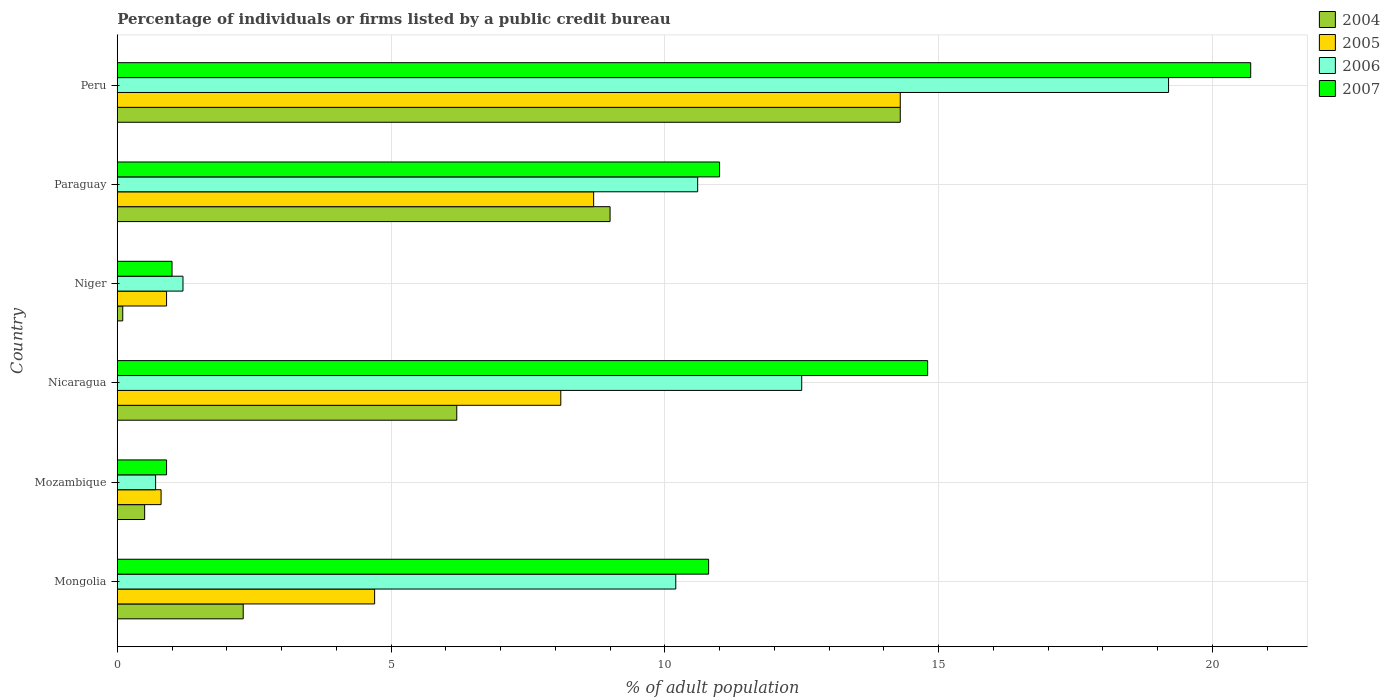How many groups of bars are there?
Give a very brief answer. 6. How many bars are there on the 4th tick from the top?
Provide a succinct answer. 4. How many bars are there on the 5th tick from the bottom?
Keep it short and to the point. 4. What is the label of the 3rd group of bars from the top?
Your response must be concise. Niger. In how many cases, is the number of bars for a given country not equal to the number of legend labels?
Provide a short and direct response. 0. Across all countries, what is the maximum percentage of population listed by a public credit bureau in 2004?
Give a very brief answer. 14.3. Across all countries, what is the minimum percentage of population listed by a public credit bureau in 2005?
Offer a very short reply. 0.8. In which country was the percentage of population listed by a public credit bureau in 2007 maximum?
Ensure brevity in your answer.  Peru. In which country was the percentage of population listed by a public credit bureau in 2005 minimum?
Ensure brevity in your answer.  Mozambique. What is the total percentage of population listed by a public credit bureau in 2006 in the graph?
Offer a very short reply. 54.4. What is the difference between the percentage of population listed by a public credit bureau in 2004 in Mongolia and that in Niger?
Give a very brief answer. 2.2. What is the average percentage of population listed by a public credit bureau in 2007 per country?
Offer a very short reply. 9.87. What is the difference between the percentage of population listed by a public credit bureau in 2004 and percentage of population listed by a public credit bureau in 2005 in Mozambique?
Provide a succinct answer. -0.3. What is the ratio of the percentage of population listed by a public credit bureau in 2004 in Paraguay to that in Peru?
Your response must be concise. 0.63. What is the difference between the highest and the second highest percentage of population listed by a public credit bureau in 2007?
Offer a terse response. 5.9. What is the difference between the highest and the lowest percentage of population listed by a public credit bureau in 2005?
Keep it short and to the point. 13.5. In how many countries, is the percentage of population listed by a public credit bureau in 2006 greater than the average percentage of population listed by a public credit bureau in 2006 taken over all countries?
Offer a very short reply. 4. Is it the case that in every country, the sum of the percentage of population listed by a public credit bureau in 2004 and percentage of population listed by a public credit bureau in 2005 is greater than the sum of percentage of population listed by a public credit bureau in 2007 and percentage of population listed by a public credit bureau in 2006?
Ensure brevity in your answer.  No. Is it the case that in every country, the sum of the percentage of population listed by a public credit bureau in 2005 and percentage of population listed by a public credit bureau in 2004 is greater than the percentage of population listed by a public credit bureau in 2007?
Your response must be concise. No. How many bars are there?
Provide a short and direct response. 24. How many countries are there in the graph?
Give a very brief answer. 6. What is the difference between two consecutive major ticks on the X-axis?
Provide a short and direct response. 5. Are the values on the major ticks of X-axis written in scientific E-notation?
Ensure brevity in your answer.  No. Does the graph contain any zero values?
Your answer should be compact. No. Does the graph contain grids?
Your response must be concise. Yes. Where does the legend appear in the graph?
Offer a terse response. Top right. What is the title of the graph?
Provide a succinct answer. Percentage of individuals or firms listed by a public credit bureau. What is the label or title of the X-axis?
Your response must be concise. % of adult population. What is the label or title of the Y-axis?
Provide a succinct answer. Country. What is the % of adult population in 2006 in Mongolia?
Ensure brevity in your answer.  10.2. What is the % of adult population of 2007 in Mongolia?
Keep it short and to the point. 10.8. What is the % of adult population in 2004 in Mozambique?
Offer a terse response. 0.5. What is the % of adult population in 2007 in Nicaragua?
Your response must be concise. 14.8. What is the % of adult population in 2004 in Niger?
Offer a very short reply. 0.1. What is the % of adult population in 2005 in Niger?
Keep it short and to the point. 0.9. What is the % of adult population of 2007 in Niger?
Your answer should be very brief. 1. What is the % of adult population in 2006 in Paraguay?
Your answer should be compact. 10.6. What is the % of adult population of 2007 in Paraguay?
Your answer should be very brief. 11. What is the % of adult population in 2004 in Peru?
Offer a very short reply. 14.3. What is the % of adult population of 2007 in Peru?
Your answer should be compact. 20.7. Across all countries, what is the maximum % of adult population in 2006?
Offer a terse response. 19.2. Across all countries, what is the maximum % of adult population in 2007?
Offer a very short reply. 20.7. Across all countries, what is the minimum % of adult population in 2007?
Provide a short and direct response. 0.9. What is the total % of adult population in 2004 in the graph?
Ensure brevity in your answer.  32.4. What is the total % of adult population in 2005 in the graph?
Offer a very short reply. 37.5. What is the total % of adult population in 2006 in the graph?
Give a very brief answer. 54.4. What is the total % of adult population in 2007 in the graph?
Offer a terse response. 59.2. What is the difference between the % of adult population of 2004 in Mongolia and that in Mozambique?
Your answer should be compact. 1.8. What is the difference between the % of adult population of 2005 in Mongolia and that in Mozambique?
Your answer should be very brief. 3.9. What is the difference between the % of adult population of 2006 in Mongolia and that in Mozambique?
Your answer should be very brief. 9.5. What is the difference between the % of adult population of 2005 in Mongolia and that in Nicaragua?
Give a very brief answer. -3.4. What is the difference between the % of adult population in 2007 in Mongolia and that in Nicaragua?
Make the answer very short. -4. What is the difference between the % of adult population in 2006 in Mongolia and that in Niger?
Make the answer very short. 9. What is the difference between the % of adult population in 2007 in Mongolia and that in Niger?
Provide a short and direct response. 9.8. What is the difference between the % of adult population of 2007 in Mongolia and that in Paraguay?
Provide a succinct answer. -0.2. What is the difference between the % of adult population in 2004 in Mongolia and that in Peru?
Provide a succinct answer. -12. What is the difference between the % of adult population of 2006 in Mongolia and that in Peru?
Make the answer very short. -9. What is the difference between the % of adult population of 2004 in Mozambique and that in Nicaragua?
Give a very brief answer. -5.7. What is the difference between the % of adult population of 2005 in Mozambique and that in Nicaragua?
Your response must be concise. -7.3. What is the difference between the % of adult population in 2006 in Mozambique and that in Niger?
Offer a terse response. -0.5. What is the difference between the % of adult population in 2007 in Mozambique and that in Niger?
Provide a succinct answer. -0.1. What is the difference between the % of adult population of 2004 in Mozambique and that in Paraguay?
Offer a very short reply. -8.5. What is the difference between the % of adult population of 2005 in Mozambique and that in Peru?
Offer a very short reply. -13.5. What is the difference between the % of adult population in 2006 in Mozambique and that in Peru?
Give a very brief answer. -18.5. What is the difference between the % of adult population of 2007 in Mozambique and that in Peru?
Your answer should be very brief. -19.8. What is the difference between the % of adult population of 2005 in Nicaragua and that in Niger?
Provide a short and direct response. 7.2. What is the difference between the % of adult population in 2004 in Nicaragua and that in Paraguay?
Provide a short and direct response. -2.8. What is the difference between the % of adult population of 2005 in Nicaragua and that in Paraguay?
Make the answer very short. -0.6. What is the difference between the % of adult population in 2004 in Nicaragua and that in Peru?
Offer a very short reply. -8.1. What is the difference between the % of adult population in 2004 in Niger and that in Paraguay?
Offer a very short reply. -8.9. What is the difference between the % of adult population in 2007 in Niger and that in Paraguay?
Provide a short and direct response. -10. What is the difference between the % of adult population in 2004 in Niger and that in Peru?
Provide a short and direct response. -14.2. What is the difference between the % of adult population in 2005 in Niger and that in Peru?
Provide a succinct answer. -13.4. What is the difference between the % of adult population in 2006 in Niger and that in Peru?
Ensure brevity in your answer.  -18. What is the difference between the % of adult population of 2007 in Niger and that in Peru?
Offer a very short reply. -19.7. What is the difference between the % of adult population in 2004 in Paraguay and that in Peru?
Your response must be concise. -5.3. What is the difference between the % of adult population of 2005 in Paraguay and that in Peru?
Provide a short and direct response. -5.6. What is the difference between the % of adult population of 2006 in Paraguay and that in Peru?
Your answer should be compact. -8.6. What is the difference between the % of adult population in 2004 in Mongolia and the % of adult population in 2007 in Mozambique?
Your answer should be compact. 1.4. What is the difference between the % of adult population in 2004 in Mongolia and the % of adult population in 2006 in Nicaragua?
Offer a terse response. -10.2. What is the difference between the % of adult population of 2005 in Mongolia and the % of adult population of 2006 in Nicaragua?
Your answer should be very brief. -7.8. What is the difference between the % of adult population in 2005 in Mongolia and the % of adult population in 2007 in Nicaragua?
Keep it short and to the point. -10.1. What is the difference between the % of adult population of 2006 in Mongolia and the % of adult population of 2007 in Nicaragua?
Make the answer very short. -4.6. What is the difference between the % of adult population in 2004 in Mongolia and the % of adult population in 2005 in Niger?
Provide a short and direct response. 1.4. What is the difference between the % of adult population of 2004 in Mongolia and the % of adult population of 2006 in Paraguay?
Provide a succinct answer. -8.3. What is the difference between the % of adult population in 2004 in Mongolia and the % of adult population in 2007 in Paraguay?
Make the answer very short. -8.7. What is the difference between the % of adult population in 2005 in Mongolia and the % of adult population in 2006 in Paraguay?
Ensure brevity in your answer.  -5.9. What is the difference between the % of adult population of 2006 in Mongolia and the % of adult population of 2007 in Paraguay?
Keep it short and to the point. -0.8. What is the difference between the % of adult population of 2004 in Mongolia and the % of adult population of 2005 in Peru?
Make the answer very short. -12. What is the difference between the % of adult population in 2004 in Mongolia and the % of adult population in 2006 in Peru?
Your response must be concise. -16.9. What is the difference between the % of adult population in 2004 in Mongolia and the % of adult population in 2007 in Peru?
Offer a very short reply. -18.4. What is the difference between the % of adult population of 2005 in Mongolia and the % of adult population of 2006 in Peru?
Give a very brief answer. -14.5. What is the difference between the % of adult population of 2004 in Mozambique and the % of adult population of 2005 in Nicaragua?
Give a very brief answer. -7.6. What is the difference between the % of adult population of 2004 in Mozambique and the % of adult population of 2007 in Nicaragua?
Your answer should be compact. -14.3. What is the difference between the % of adult population of 2006 in Mozambique and the % of adult population of 2007 in Nicaragua?
Keep it short and to the point. -14.1. What is the difference between the % of adult population of 2004 in Mozambique and the % of adult population of 2006 in Niger?
Provide a succinct answer. -0.7. What is the difference between the % of adult population in 2004 in Mozambique and the % of adult population in 2007 in Niger?
Offer a terse response. -0.5. What is the difference between the % of adult population of 2005 in Mozambique and the % of adult population of 2006 in Niger?
Ensure brevity in your answer.  -0.4. What is the difference between the % of adult population in 2005 in Mozambique and the % of adult population in 2007 in Niger?
Provide a succinct answer. -0.2. What is the difference between the % of adult population of 2006 in Mozambique and the % of adult population of 2007 in Niger?
Keep it short and to the point. -0.3. What is the difference between the % of adult population in 2004 in Mozambique and the % of adult population in 2005 in Paraguay?
Provide a succinct answer. -8.2. What is the difference between the % of adult population of 2006 in Mozambique and the % of adult population of 2007 in Paraguay?
Offer a very short reply. -10.3. What is the difference between the % of adult population of 2004 in Mozambique and the % of adult population of 2006 in Peru?
Provide a short and direct response. -18.7. What is the difference between the % of adult population in 2004 in Mozambique and the % of adult population in 2007 in Peru?
Your answer should be compact. -20.2. What is the difference between the % of adult population in 2005 in Mozambique and the % of adult population in 2006 in Peru?
Offer a terse response. -18.4. What is the difference between the % of adult population in 2005 in Mozambique and the % of adult population in 2007 in Peru?
Give a very brief answer. -19.9. What is the difference between the % of adult population in 2004 in Nicaragua and the % of adult population in 2005 in Niger?
Your answer should be very brief. 5.3. What is the difference between the % of adult population of 2004 in Nicaragua and the % of adult population of 2006 in Niger?
Your answer should be compact. 5. What is the difference between the % of adult population of 2004 in Nicaragua and the % of adult population of 2007 in Niger?
Give a very brief answer. 5.2. What is the difference between the % of adult population of 2005 in Nicaragua and the % of adult population of 2007 in Niger?
Your answer should be compact. 7.1. What is the difference between the % of adult population in 2004 in Nicaragua and the % of adult population in 2005 in Paraguay?
Your answer should be compact. -2.5. What is the difference between the % of adult population in 2005 in Nicaragua and the % of adult population in 2007 in Paraguay?
Offer a terse response. -2.9. What is the difference between the % of adult population in 2004 in Nicaragua and the % of adult population in 2005 in Peru?
Provide a succinct answer. -8.1. What is the difference between the % of adult population in 2004 in Nicaragua and the % of adult population in 2006 in Peru?
Your answer should be compact. -13. What is the difference between the % of adult population in 2005 in Nicaragua and the % of adult population in 2006 in Peru?
Make the answer very short. -11.1. What is the difference between the % of adult population of 2006 in Nicaragua and the % of adult population of 2007 in Peru?
Make the answer very short. -8.2. What is the difference between the % of adult population of 2004 in Niger and the % of adult population of 2007 in Paraguay?
Give a very brief answer. -10.9. What is the difference between the % of adult population of 2005 in Niger and the % of adult population of 2006 in Paraguay?
Keep it short and to the point. -9.7. What is the difference between the % of adult population in 2005 in Niger and the % of adult population in 2007 in Paraguay?
Give a very brief answer. -10.1. What is the difference between the % of adult population of 2004 in Niger and the % of adult population of 2006 in Peru?
Provide a short and direct response. -19.1. What is the difference between the % of adult population of 2004 in Niger and the % of adult population of 2007 in Peru?
Offer a very short reply. -20.6. What is the difference between the % of adult population in 2005 in Niger and the % of adult population in 2006 in Peru?
Ensure brevity in your answer.  -18.3. What is the difference between the % of adult population of 2005 in Niger and the % of adult population of 2007 in Peru?
Your response must be concise. -19.8. What is the difference between the % of adult population in 2006 in Niger and the % of adult population in 2007 in Peru?
Your answer should be very brief. -19.5. What is the difference between the % of adult population of 2004 in Paraguay and the % of adult population of 2005 in Peru?
Your answer should be very brief. -5.3. What is the difference between the % of adult population in 2004 in Paraguay and the % of adult population in 2006 in Peru?
Your answer should be very brief. -10.2. What is the difference between the % of adult population in 2004 in Paraguay and the % of adult population in 2007 in Peru?
Give a very brief answer. -11.7. What is the difference between the % of adult population in 2005 in Paraguay and the % of adult population in 2006 in Peru?
Your response must be concise. -10.5. What is the difference between the % of adult population in 2005 in Paraguay and the % of adult population in 2007 in Peru?
Keep it short and to the point. -12. What is the difference between the % of adult population of 2006 in Paraguay and the % of adult population of 2007 in Peru?
Offer a very short reply. -10.1. What is the average % of adult population in 2004 per country?
Your response must be concise. 5.4. What is the average % of adult population of 2005 per country?
Keep it short and to the point. 6.25. What is the average % of adult population in 2006 per country?
Your answer should be very brief. 9.07. What is the average % of adult population in 2007 per country?
Your answer should be very brief. 9.87. What is the difference between the % of adult population of 2004 and % of adult population of 2006 in Mongolia?
Your response must be concise. -7.9. What is the difference between the % of adult population in 2005 and % of adult population in 2007 in Mongolia?
Provide a short and direct response. -6.1. What is the difference between the % of adult population in 2006 and % of adult population in 2007 in Mongolia?
Your answer should be very brief. -0.6. What is the difference between the % of adult population in 2004 and % of adult population in 2006 in Mozambique?
Keep it short and to the point. -0.2. What is the difference between the % of adult population in 2004 and % of adult population in 2007 in Mozambique?
Keep it short and to the point. -0.4. What is the difference between the % of adult population in 2005 and % of adult population in 2006 in Mozambique?
Keep it short and to the point. 0.1. What is the difference between the % of adult population in 2006 and % of adult population in 2007 in Mozambique?
Your answer should be very brief. -0.2. What is the difference between the % of adult population of 2004 and % of adult population of 2005 in Nicaragua?
Give a very brief answer. -1.9. What is the difference between the % of adult population in 2004 and % of adult population in 2006 in Nicaragua?
Keep it short and to the point. -6.3. What is the difference between the % of adult population of 2005 and % of adult population of 2006 in Nicaragua?
Your answer should be very brief. -4.4. What is the difference between the % of adult population in 2005 and % of adult population in 2007 in Nicaragua?
Offer a very short reply. -6.7. What is the difference between the % of adult population of 2004 and % of adult population of 2005 in Niger?
Provide a short and direct response. -0.8. What is the difference between the % of adult population of 2004 and % of adult population of 2006 in Niger?
Provide a short and direct response. -1.1. What is the difference between the % of adult population in 2005 and % of adult population in 2007 in Niger?
Your answer should be compact. -0.1. What is the difference between the % of adult population of 2006 and % of adult population of 2007 in Niger?
Offer a very short reply. 0.2. What is the difference between the % of adult population of 2004 and % of adult population of 2005 in Paraguay?
Your answer should be very brief. 0.3. What is the difference between the % of adult population in 2004 and % of adult population in 2007 in Paraguay?
Provide a short and direct response. -2. What is the difference between the % of adult population in 2006 and % of adult population in 2007 in Paraguay?
Offer a very short reply. -0.4. What is the difference between the % of adult population in 2004 and % of adult population in 2005 in Peru?
Your answer should be compact. 0. What is the difference between the % of adult population of 2004 and % of adult population of 2007 in Peru?
Ensure brevity in your answer.  -6.4. What is the difference between the % of adult population of 2005 and % of adult population of 2006 in Peru?
Offer a very short reply. -4.9. What is the difference between the % of adult population of 2006 and % of adult population of 2007 in Peru?
Your answer should be very brief. -1.5. What is the ratio of the % of adult population of 2004 in Mongolia to that in Mozambique?
Provide a short and direct response. 4.6. What is the ratio of the % of adult population of 2005 in Mongolia to that in Mozambique?
Provide a short and direct response. 5.88. What is the ratio of the % of adult population in 2006 in Mongolia to that in Mozambique?
Ensure brevity in your answer.  14.57. What is the ratio of the % of adult population of 2007 in Mongolia to that in Mozambique?
Give a very brief answer. 12. What is the ratio of the % of adult population in 2004 in Mongolia to that in Nicaragua?
Your answer should be compact. 0.37. What is the ratio of the % of adult population of 2005 in Mongolia to that in Nicaragua?
Your answer should be very brief. 0.58. What is the ratio of the % of adult population in 2006 in Mongolia to that in Nicaragua?
Keep it short and to the point. 0.82. What is the ratio of the % of adult population in 2007 in Mongolia to that in Nicaragua?
Give a very brief answer. 0.73. What is the ratio of the % of adult population in 2004 in Mongolia to that in Niger?
Your response must be concise. 23. What is the ratio of the % of adult population in 2005 in Mongolia to that in Niger?
Give a very brief answer. 5.22. What is the ratio of the % of adult population of 2007 in Mongolia to that in Niger?
Offer a terse response. 10.8. What is the ratio of the % of adult population of 2004 in Mongolia to that in Paraguay?
Offer a very short reply. 0.26. What is the ratio of the % of adult population of 2005 in Mongolia to that in Paraguay?
Provide a succinct answer. 0.54. What is the ratio of the % of adult population of 2006 in Mongolia to that in Paraguay?
Offer a terse response. 0.96. What is the ratio of the % of adult population of 2007 in Mongolia to that in Paraguay?
Make the answer very short. 0.98. What is the ratio of the % of adult population of 2004 in Mongolia to that in Peru?
Keep it short and to the point. 0.16. What is the ratio of the % of adult population in 2005 in Mongolia to that in Peru?
Give a very brief answer. 0.33. What is the ratio of the % of adult population of 2006 in Mongolia to that in Peru?
Your response must be concise. 0.53. What is the ratio of the % of adult population of 2007 in Mongolia to that in Peru?
Your response must be concise. 0.52. What is the ratio of the % of adult population of 2004 in Mozambique to that in Nicaragua?
Provide a short and direct response. 0.08. What is the ratio of the % of adult population in 2005 in Mozambique to that in Nicaragua?
Ensure brevity in your answer.  0.1. What is the ratio of the % of adult population in 2006 in Mozambique to that in Nicaragua?
Provide a succinct answer. 0.06. What is the ratio of the % of adult population of 2007 in Mozambique to that in Nicaragua?
Make the answer very short. 0.06. What is the ratio of the % of adult population in 2004 in Mozambique to that in Niger?
Your answer should be very brief. 5. What is the ratio of the % of adult population in 2006 in Mozambique to that in Niger?
Keep it short and to the point. 0.58. What is the ratio of the % of adult population in 2004 in Mozambique to that in Paraguay?
Your answer should be very brief. 0.06. What is the ratio of the % of adult population in 2005 in Mozambique to that in Paraguay?
Your answer should be very brief. 0.09. What is the ratio of the % of adult population in 2006 in Mozambique to that in Paraguay?
Your response must be concise. 0.07. What is the ratio of the % of adult population of 2007 in Mozambique to that in Paraguay?
Your answer should be compact. 0.08. What is the ratio of the % of adult population in 2004 in Mozambique to that in Peru?
Offer a terse response. 0.04. What is the ratio of the % of adult population of 2005 in Mozambique to that in Peru?
Offer a terse response. 0.06. What is the ratio of the % of adult population of 2006 in Mozambique to that in Peru?
Offer a terse response. 0.04. What is the ratio of the % of adult population of 2007 in Mozambique to that in Peru?
Make the answer very short. 0.04. What is the ratio of the % of adult population of 2005 in Nicaragua to that in Niger?
Offer a very short reply. 9. What is the ratio of the % of adult population in 2006 in Nicaragua to that in Niger?
Give a very brief answer. 10.42. What is the ratio of the % of adult population in 2007 in Nicaragua to that in Niger?
Provide a succinct answer. 14.8. What is the ratio of the % of adult population in 2004 in Nicaragua to that in Paraguay?
Give a very brief answer. 0.69. What is the ratio of the % of adult population of 2006 in Nicaragua to that in Paraguay?
Offer a very short reply. 1.18. What is the ratio of the % of adult population of 2007 in Nicaragua to that in Paraguay?
Offer a very short reply. 1.35. What is the ratio of the % of adult population of 2004 in Nicaragua to that in Peru?
Offer a terse response. 0.43. What is the ratio of the % of adult population of 2005 in Nicaragua to that in Peru?
Make the answer very short. 0.57. What is the ratio of the % of adult population in 2006 in Nicaragua to that in Peru?
Provide a short and direct response. 0.65. What is the ratio of the % of adult population of 2007 in Nicaragua to that in Peru?
Offer a very short reply. 0.71. What is the ratio of the % of adult population of 2004 in Niger to that in Paraguay?
Give a very brief answer. 0.01. What is the ratio of the % of adult population of 2005 in Niger to that in Paraguay?
Your response must be concise. 0.1. What is the ratio of the % of adult population in 2006 in Niger to that in Paraguay?
Provide a succinct answer. 0.11. What is the ratio of the % of adult population in 2007 in Niger to that in Paraguay?
Your answer should be very brief. 0.09. What is the ratio of the % of adult population in 2004 in Niger to that in Peru?
Your answer should be very brief. 0.01. What is the ratio of the % of adult population of 2005 in Niger to that in Peru?
Provide a short and direct response. 0.06. What is the ratio of the % of adult population in 2006 in Niger to that in Peru?
Provide a short and direct response. 0.06. What is the ratio of the % of adult population in 2007 in Niger to that in Peru?
Provide a short and direct response. 0.05. What is the ratio of the % of adult population in 2004 in Paraguay to that in Peru?
Provide a succinct answer. 0.63. What is the ratio of the % of adult population in 2005 in Paraguay to that in Peru?
Provide a short and direct response. 0.61. What is the ratio of the % of adult population of 2006 in Paraguay to that in Peru?
Give a very brief answer. 0.55. What is the ratio of the % of adult population of 2007 in Paraguay to that in Peru?
Keep it short and to the point. 0.53. What is the difference between the highest and the second highest % of adult population of 2007?
Make the answer very short. 5.9. What is the difference between the highest and the lowest % of adult population of 2007?
Provide a short and direct response. 19.8. 